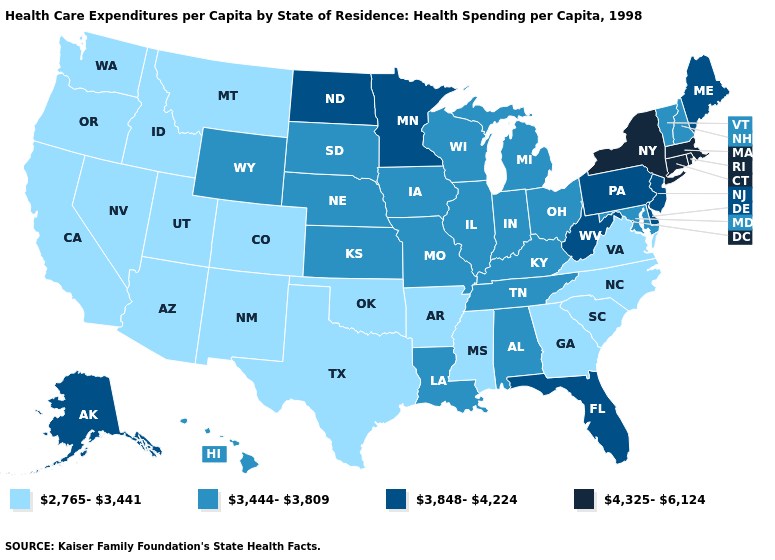What is the highest value in states that border Arkansas?
Short answer required. 3,444-3,809. What is the lowest value in the USA?
Give a very brief answer. 2,765-3,441. Name the states that have a value in the range 3,444-3,809?
Answer briefly. Alabama, Hawaii, Illinois, Indiana, Iowa, Kansas, Kentucky, Louisiana, Maryland, Michigan, Missouri, Nebraska, New Hampshire, Ohio, South Dakota, Tennessee, Vermont, Wisconsin, Wyoming. Name the states that have a value in the range 3,848-4,224?
Give a very brief answer. Alaska, Delaware, Florida, Maine, Minnesota, New Jersey, North Dakota, Pennsylvania, West Virginia. Name the states that have a value in the range 4,325-6,124?
Short answer required. Connecticut, Massachusetts, New York, Rhode Island. What is the value of Illinois?
Short answer required. 3,444-3,809. What is the value of Oregon?
Be succinct. 2,765-3,441. What is the value of Wisconsin?
Be succinct. 3,444-3,809. Name the states that have a value in the range 3,848-4,224?
Answer briefly. Alaska, Delaware, Florida, Maine, Minnesota, New Jersey, North Dakota, Pennsylvania, West Virginia. What is the value of Maine?
Keep it brief. 3,848-4,224. Does the map have missing data?
Answer briefly. No. What is the highest value in the USA?
Be succinct. 4,325-6,124. What is the value of Kentucky?
Answer briefly. 3,444-3,809. How many symbols are there in the legend?
Short answer required. 4. What is the value of Pennsylvania?
Keep it brief. 3,848-4,224. 